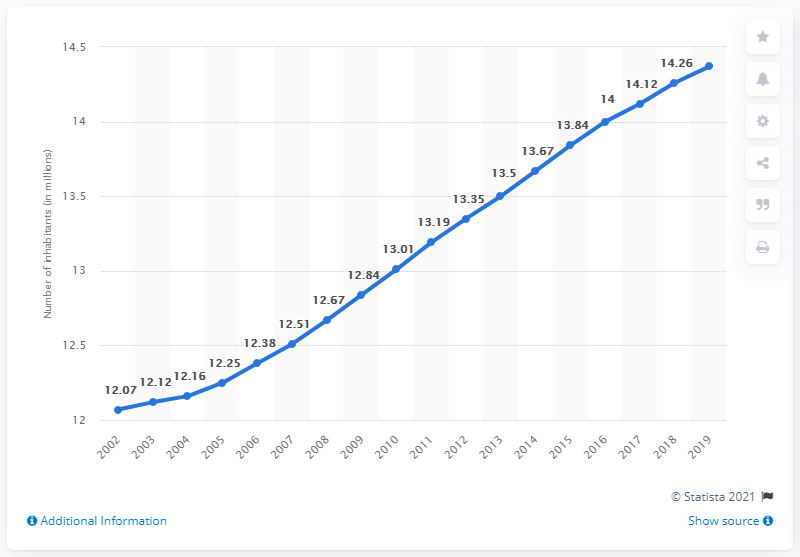List a handful of essential elements in this visual. In 2019, the population of the London metropolitan area was approximately 14.37 million. The difference between the 2010 and 2011 model years is 0.18. In 2019, the population reached its maximum. 